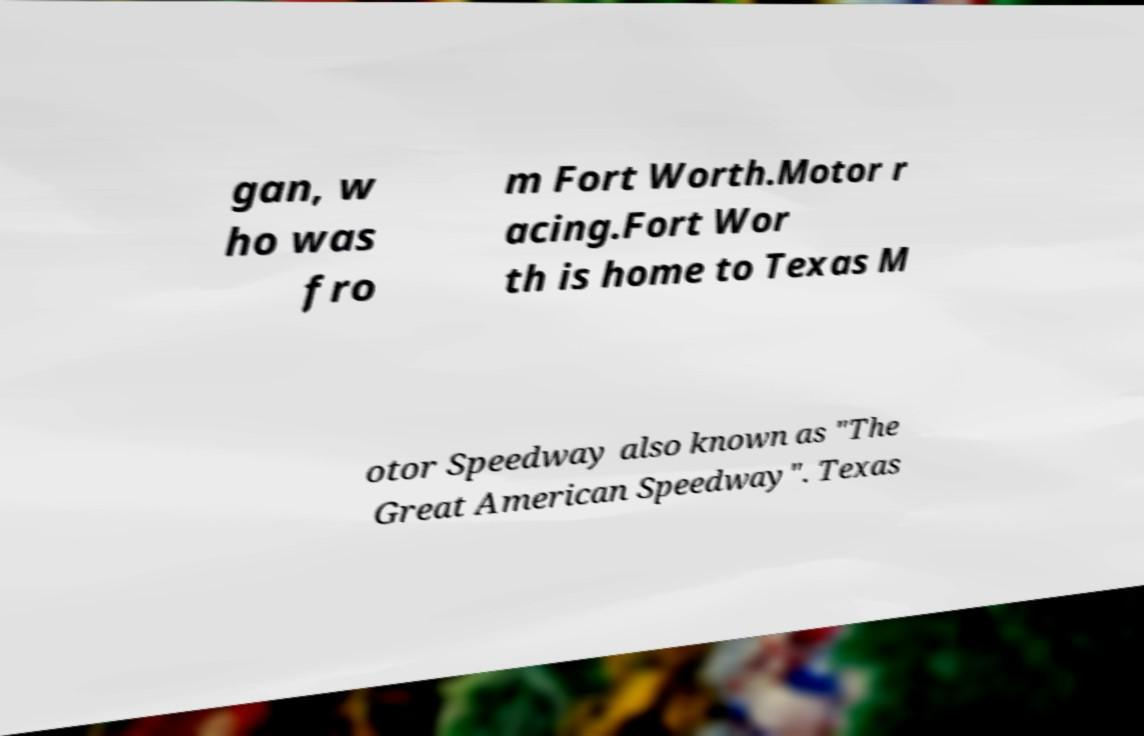Please identify and transcribe the text found in this image. gan, w ho was fro m Fort Worth.Motor r acing.Fort Wor th is home to Texas M otor Speedway also known as "The Great American Speedway". Texas 